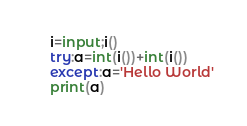Convert code to text. <code><loc_0><loc_0><loc_500><loc_500><_Python_>i=input;i()
try:a=int(i())+int(i())
except:a='Hello World'
print(a)</code> 